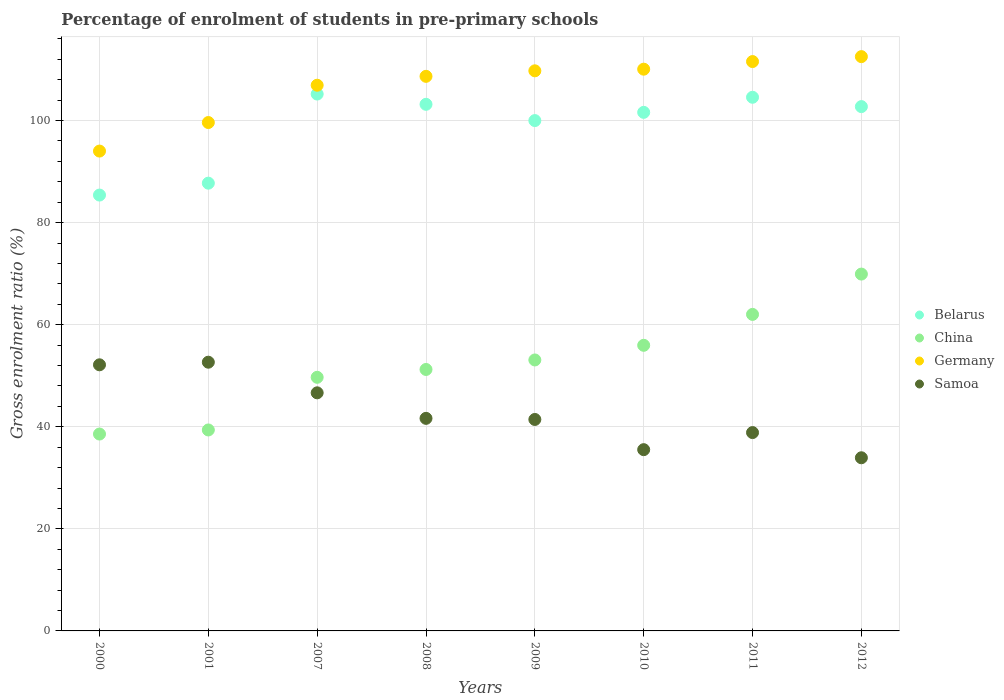How many different coloured dotlines are there?
Offer a very short reply. 4. Is the number of dotlines equal to the number of legend labels?
Your answer should be very brief. Yes. What is the percentage of students enrolled in pre-primary schools in Samoa in 2009?
Your answer should be very brief. 41.43. Across all years, what is the maximum percentage of students enrolled in pre-primary schools in Belarus?
Provide a short and direct response. 105.18. Across all years, what is the minimum percentage of students enrolled in pre-primary schools in Germany?
Provide a short and direct response. 94.01. What is the total percentage of students enrolled in pre-primary schools in China in the graph?
Offer a very short reply. 419.84. What is the difference between the percentage of students enrolled in pre-primary schools in Germany in 2000 and that in 2011?
Make the answer very short. -17.54. What is the difference between the percentage of students enrolled in pre-primary schools in Germany in 2000 and the percentage of students enrolled in pre-primary schools in Belarus in 2007?
Give a very brief answer. -11.17. What is the average percentage of students enrolled in pre-primary schools in Germany per year?
Offer a very short reply. 106.63. In the year 2007, what is the difference between the percentage of students enrolled in pre-primary schools in Germany and percentage of students enrolled in pre-primary schools in Samoa?
Provide a succinct answer. 60.27. In how many years, is the percentage of students enrolled in pre-primary schools in China greater than 28 %?
Provide a succinct answer. 8. What is the ratio of the percentage of students enrolled in pre-primary schools in Germany in 2010 to that in 2012?
Your answer should be compact. 0.98. Is the difference between the percentage of students enrolled in pre-primary schools in Germany in 2001 and 2009 greater than the difference between the percentage of students enrolled in pre-primary schools in Samoa in 2001 and 2009?
Keep it short and to the point. No. What is the difference between the highest and the second highest percentage of students enrolled in pre-primary schools in Belarus?
Keep it short and to the point. 0.63. What is the difference between the highest and the lowest percentage of students enrolled in pre-primary schools in Germany?
Your response must be concise. 18.5. In how many years, is the percentage of students enrolled in pre-primary schools in Belarus greater than the average percentage of students enrolled in pre-primary schools in Belarus taken over all years?
Keep it short and to the point. 6. Is it the case that in every year, the sum of the percentage of students enrolled in pre-primary schools in Samoa and percentage of students enrolled in pre-primary schools in Germany  is greater than the sum of percentage of students enrolled in pre-primary schools in Belarus and percentage of students enrolled in pre-primary schools in China?
Offer a terse response. Yes. Does the percentage of students enrolled in pre-primary schools in Germany monotonically increase over the years?
Make the answer very short. Yes. Is the percentage of students enrolled in pre-primary schools in Samoa strictly less than the percentage of students enrolled in pre-primary schools in China over the years?
Offer a terse response. No. How many dotlines are there?
Ensure brevity in your answer.  4. How many years are there in the graph?
Make the answer very short. 8. Where does the legend appear in the graph?
Provide a succinct answer. Center right. How many legend labels are there?
Your answer should be compact. 4. What is the title of the graph?
Your answer should be compact. Percentage of enrolment of students in pre-primary schools. What is the label or title of the Y-axis?
Give a very brief answer. Gross enrolment ratio (%). What is the Gross enrolment ratio (%) of Belarus in 2000?
Make the answer very short. 85.39. What is the Gross enrolment ratio (%) in China in 2000?
Provide a short and direct response. 38.57. What is the Gross enrolment ratio (%) of Germany in 2000?
Offer a very short reply. 94.01. What is the Gross enrolment ratio (%) of Samoa in 2000?
Give a very brief answer. 52.14. What is the Gross enrolment ratio (%) of Belarus in 2001?
Your answer should be compact. 87.73. What is the Gross enrolment ratio (%) in China in 2001?
Your response must be concise. 39.37. What is the Gross enrolment ratio (%) of Germany in 2001?
Your response must be concise. 99.6. What is the Gross enrolment ratio (%) of Samoa in 2001?
Keep it short and to the point. 52.65. What is the Gross enrolment ratio (%) in Belarus in 2007?
Offer a terse response. 105.18. What is the Gross enrolment ratio (%) in China in 2007?
Offer a very short reply. 49.69. What is the Gross enrolment ratio (%) in Germany in 2007?
Provide a short and direct response. 106.91. What is the Gross enrolment ratio (%) of Samoa in 2007?
Provide a succinct answer. 46.65. What is the Gross enrolment ratio (%) in Belarus in 2008?
Make the answer very short. 103.17. What is the Gross enrolment ratio (%) in China in 2008?
Your answer should be compact. 51.22. What is the Gross enrolment ratio (%) in Germany in 2008?
Ensure brevity in your answer.  108.66. What is the Gross enrolment ratio (%) in Samoa in 2008?
Your response must be concise. 41.65. What is the Gross enrolment ratio (%) in Belarus in 2009?
Your answer should be very brief. 99.99. What is the Gross enrolment ratio (%) in China in 2009?
Ensure brevity in your answer.  53.09. What is the Gross enrolment ratio (%) of Germany in 2009?
Your answer should be very brief. 109.74. What is the Gross enrolment ratio (%) of Samoa in 2009?
Your response must be concise. 41.43. What is the Gross enrolment ratio (%) in Belarus in 2010?
Your response must be concise. 101.6. What is the Gross enrolment ratio (%) in China in 2010?
Your response must be concise. 55.96. What is the Gross enrolment ratio (%) of Germany in 2010?
Your answer should be very brief. 110.06. What is the Gross enrolment ratio (%) of Samoa in 2010?
Ensure brevity in your answer.  35.51. What is the Gross enrolment ratio (%) in Belarus in 2011?
Keep it short and to the point. 104.56. What is the Gross enrolment ratio (%) of China in 2011?
Make the answer very short. 62.01. What is the Gross enrolment ratio (%) of Germany in 2011?
Keep it short and to the point. 111.55. What is the Gross enrolment ratio (%) of Samoa in 2011?
Your response must be concise. 38.86. What is the Gross enrolment ratio (%) in Belarus in 2012?
Keep it short and to the point. 102.73. What is the Gross enrolment ratio (%) of China in 2012?
Provide a succinct answer. 69.91. What is the Gross enrolment ratio (%) of Germany in 2012?
Provide a succinct answer. 112.52. What is the Gross enrolment ratio (%) of Samoa in 2012?
Your answer should be very brief. 33.92. Across all years, what is the maximum Gross enrolment ratio (%) in Belarus?
Make the answer very short. 105.18. Across all years, what is the maximum Gross enrolment ratio (%) in China?
Keep it short and to the point. 69.91. Across all years, what is the maximum Gross enrolment ratio (%) of Germany?
Your response must be concise. 112.52. Across all years, what is the maximum Gross enrolment ratio (%) of Samoa?
Provide a succinct answer. 52.65. Across all years, what is the minimum Gross enrolment ratio (%) of Belarus?
Offer a very short reply. 85.39. Across all years, what is the minimum Gross enrolment ratio (%) in China?
Make the answer very short. 38.57. Across all years, what is the minimum Gross enrolment ratio (%) of Germany?
Provide a short and direct response. 94.01. Across all years, what is the minimum Gross enrolment ratio (%) of Samoa?
Ensure brevity in your answer.  33.92. What is the total Gross enrolment ratio (%) of Belarus in the graph?
Your response must be concise. 790.35. What is the total Gross enrolment ratio (%) in China in the graph?
Keep it short and to the point. 419.84. What is the total Gross enrolment ratio (%) in Germany in the graph?
Give a very brief answer. 853.05. What is the total Gross enrolment ratio (%) of Samoa in the graph?
Offer a terse response. 342.81. What is the difference between the Gross enrolment ratio (%) of Belarus in 2000 and that in 2001?
Offer a terse response. -2.33. What is the difference between the Gross enrolment ratio (%) in China in 2000 and that in 2001?
Make the answer very short. -0.8. What is the difference between the Gross enrolment ratio (%) of Germany in 2000 and that in 2001?
Ensure brevity in your answer.  -5.59. What is the difference between the Gross enrolment ratio (%) in Samoa in 2000 and that in 2001?
Provide a succinct answer. -0.51. What is the difference between the Gross enrolment ratio (%) in Belarus in 2000 and that in 2007?
Provide a succinct answer. -19.79. What is the difference between the Gross enrolment ratio (%) of China in 2000 and that in 2007?
Make the answer very short. -11.12. What is the difference between the Gross enrolment ratio (%) of Germany in 2000 and that in 2007?
Your response must be concise. -12.9. What is the difference between the Gross enrolment ratio (%) in Samoa in 2000 and that in 2007?
Ensure brevity in your answer.  5.49. What is the difference between the Gross enrolment ratio (%) in Belarus in 2000 and that in 2008?
Ensure brevity in your answer.  -17.78. What is the difference between the Gross enrolment ratio (%) in China in 2000 and that in 2008?
Your answer should be very brief. -12.65. What is the difference between the Gross enrolment ratio (%) in Germany in 2000 and that in 2008?
Provide a succinct answer. -14.64. What is the difference between the Gross enrolment ratio (%) in Samoa in 2000 and that in 2008?
Provide a succinct answer. 10.49. What is the difference between the Gross enrolment ratio (%) of Belarus in 2000 and that in 2009?
Your answer should be very brief. -14.59. What is the difference between the Gross enrolment ratio (%) in China in 2000 and that in 2009?
Provide a succinct answer. -14.51. What is the difference between the Gross enrolment ratio (%) in Germany in 2000 and that in 2009?
Ensure brevity in your answer.  -15.72. What is the difference between the Gross enrolment ratio (%) of Samoa in 2000 and that in 2009?
Offer a terse response. 10.71. What is the difference between the Gross enrolment ratio (%) of Belarus in 2000 and that in 2010?
Your answer should be compact. -16.21. What is the difference between the Gross enrolment ratio (%) in China in 2000 and that in 2010?
Your answer should be compact. -17.38. What is the difference between the Gross enrolment ratio (%) of Germany in 2000 and that in 2010?
Keep it short and to the point. -16.05. What is the difference between the Gross enrolment ratio (%) in Samoa in 2000 and that in 2010?
Keep it short and to the point. 16.62. What is the difference between the Gross enrolment ratio (%) in Belarus in 2000 and that in 2011?
Provide a short and direct response. -19.16. What is the difference between the Gross enrolment ratio (%) in China in 2000 and that in 2011?
Ensure brevity in your answer.  -23.44. What is the difference between the Gross enrolment ratio (%) in Germany in 2000 and that in 2011?
Provide a succinct answer. -17.54. What is the difference between the Gross enrolment ratio (%) of Samoa in 2000 and that in 2011?
Provide a short and direct response. 13.28. What is the difference between the Gross enrolment ratio (%) of Belarus in 2000 and that in 2012?
Offer a terse response. -17.33. What is the difference between the Gross enrolment ratio (%) of China in 2000 and that in 2012?
Ensure brevity in your answer.  -31.34. What is the difference between the Gross enrolment ratio (%) of Germany in 2000 and that in 2012?
Keep it short and to the point. -18.5. What is the difference between the Gross enrolment ratio (%) in Samoa in 2000 and that in 2012?
Provide a succinct answer. 18.21. What is the difference between the Gross enrolment ratio (%) of Belarus in 2001 and that in 2007?
Offer a terse response. -17.46. What is the difference between the Gross enrolment ratio (%) in China in 2001 and that in 2007?
Make the answer very short. -10.32. What is the difference between the Gross enrolment ratio (%) in Germany in 2001 and that in 2007?
Provide a succinct answer. -7.31. What is the difference between the Gross enrolment ratio (%) of Samoa in 2001 and that in 2007?
Offer a very short reply. 6. What is the difference between the Gross enrolment ratio (%) in Belarus in 2001 and that in 2008?
Make the answer very short. -15.45. What is the difference between the Gross enrolment ratio (%) in China in 2001 and that in 2008?
Your response must be concise. -11.85. What is the difference between the Gross enrolment ratio (%) of Germany in 2001 and that in 2008?
Make the answer very short. -9.05. What is the difference between the Gross enrolment ratio (%) of Samoa in 2001 and that in 2008?
Give a very brief answer. 11. What is the difference between the Gross enrolment ratio (%) in Belarus in 2001 and that in 2009?
Your answer should be compact. -12.26. What is the difference between the Gross enrolment ratio (%) of China in 2001 and that in 2009?
Your answer should be very brief. -13.71. What is the difference between the Gross enrolment ratio (%) of Germany in 2001 and that in 2009?
Keep it short and to the point. -10.13. What is the difference between the Gross enrolment ratio (%) of Samoa in 2001 and that in 2009?
Keep it short and to the point. 11.22. What is the difference between the Gross enrolment ratio (%) of Belarus in 2001 and that in 2010?
Provide a succinct answer. -13.87. What is the difference between the Gross enrolment ratio (%) in China in 2001 and that in 2010?
Make the answer very short. -16.59. What is the difference between the Gross enrolment ratio (%) in Germany in 2001 and that in 2010?
Keep it short and to the point. -10.45. What is the difference between the Gross enrolment ratio (%) of Samoa in 2001 and that in 2010?
Offer a very short reply. 17.14. What is the difference between the Gross enrolment ratio (%) in Belarus in 2001 and that in 2011?
Provide a succinct answer. -16.83. What is the difference between the Gross enrolment ratio (%) of China in 2001 and that in 2011?
Your answer should be very brief. -22.64. What is the difference between the Gross enrolment ratio (%) of Germany in 2001 and that in 2011?
Provide a succinct answer. -11.95. What is the difference between the Gross enrolment ratio (%) of Samoa in 2001 and that in 2011?
Offer a terse response. 13.79. What is the difference between the Gross enrolment ratio (%) in Belarus in 2001 and that in 2012?
Provide a short and direct response. -15. What is the difference between the Gross enrolment ratio (%) of China in 2001 and that in 2012?
Offer a very short reply. -30.54. What is the difference between the Gross enrolment ratio (%) in Germany in 2001 and that in 2012?
Give a very brief answer. -12.91. What is the difference between the Gross enrolment ratio (%) in Samoa in 2001 and that in 2012?
Keep it short and to the point. 18.72. What is the difference between the Gross enrolment ratio (%) of Belarus in 2007 and that in 2008?
Ensure brevity in your answer.  2.01. What is the difference between the Gross enrolment ratio (%) in China in 2007 and that in 2008?
Ensure brevity in your answer.  -1.54. What is the difference between the Gross enrolment ratio (%) in Germany in 2007 and that in 2008?
Give a very brief answer. -1.74. What is the difference between the Gross enrolment ratio (%) in Samoa in 2007 and that in 2008?
Your answer should be very brief. 5. What is the difference between the Gross enrolment ratio (%) of Belarus in 2007 and that in 2009?
Make the answer very short. 5.2. What is the difference between the Gross enrolment ratio (%) of China in 2007 and that in 2009?
Provide a succinct answer. -3.4. What is the difference between the Gross enrolment ratio (%) of Germany in 2007 and that in 2009?
Your answer should be compact. -2.82. What is the difference between the Gross enrolment ratio (%) of Samoa in 2007 and that in 2009?
Offer a terse response. 5.22. What is the difference between the Gross enrolment ratio (%) of Belarus in 2007 and that in 2010?
Provide a short and direct response. 3.58. What is the difference between the Gross enrolment ratio (%) of China in 2007 and that in 2010?
Keep it short and to the point. -6.27. What is the difference between the Gross enrolment ratio (%) of Germany in 2007 and that in 2010?
Make the answer very short. -3.15. What is the difference between the Gross enrolment ratio (%) of Samoa in 2007 and that in 2010?
Make the answer very short. 11.13. What is the difference between the Gross enrolment ratio (%) in Belarus in 2007 and that in 2011?
Provide a short and direct response. 0.63. What is the difference between the Gross enrolment ratio (%) in China in 2007 and that in 2011?
Keep it short and to the point. -12.32. What is the difference between the Gross enrolment ratio (%) of Germany in 2007 and that in 2011?
Give a very brief answer. -4.64. What is the difference between the Gross enrolment ratio (%) of Samoa in 2007 and that in 2011?
Give a very brief answer. 7.79. What is the difference between the Gross enrolment ratio (%) in Belarus in 2007 and that in 2012?
Offer a terse response. 2.46. What is the difference between the Gross enrolment ratio (%) of China in 2007 and that in 2012?
Your answer should be compact. -20.22. What is the difference between the Gross enrolment ratio (%) in Germany in 2007 and that in 2012?
Ensure brevity in your answer.  -5.6. What is the difference between the Gross enrolment ratio (%) in Samoa in 2007 and that in 2012?
Give a very brief answer. 12.72. What is the difference between the Gross enrolment ratio (%) in Belarus in 2008 and that in 2009?
Your answer should be compact. 3.19. What is the difference between the Gross enrolment ratio (%) in China in 2008 and that in 2009?
Your answer should be very brief. -1.86. What is the difference between the Gross enrolment ratio (%) in Germany in 2008 and that in 2009?
Ensure brevity in your answer.  -1.08. What is the difference between the Gross enrolment ratio (%) in Samoa in 2008 and that in 2009?
Give a very brief answer. 0.22. What is the difference between the Gross enrolment ratio (%) in Belarus in 2008 and that in 2010?
Provide a succinct answer. 1.57. What is the difference between the Gross enrolment ratio (%) in China in 2008 and that in 2010?
Keep it short and to the point. -4.73. What is the difference between the Gross enrolment ratio (%) in Germany in 2008 and that in 2010?
Provide a short and direct response. -1.4. What is the difference between the Gross enrolment ratio (%) of Samoa in 2008 and that in 2010?
Give a very brief answer. 6.13. What is the difference between the Gross enrolment ratio (%) of Belarus in 2008 and that in 2011?
Provide a short and direct response. -1.38. What is the difference between the Gross enrolment ratio (%) of China in 2008 and that in 2011?
Your response must be concise. -10.79. What is the difference between the Gross enrolment ratio (%) in Germany in 2008 and that in 2011?
Keep it short and to the point. -2.89. What is the difference between the Gross enrolment ratio (%) in Samoa in 2008 and that in 2011?
Offer a very short reply. 2.79. What is the difference between the Gross enrolment ratio (%) of Belarus in 2008 and that in 2012?
Offer a very short reply. 0.45. What is the difference between the Gross enrolment ratio (%) of China in 2008 and that in 2012?
Provide a succinct answer. -18.69. What is the difference between the Gross enrolment ratio (%) of Germany in 2008 and that in 2012?
Offer a terse response. -3.86. What is the difference between the Gross enrolment ratio (%) of Samoa in 2008 and that in 2012?
Offer a very short reply. 7.72. What is the difference between the Gross enrolment ratio (%) of Belarus in 2009 and that in 2010?
Keep it short and to the point. -1.61. What is the difference between the Gross enrolment ratio (%) in China in 2009 and that in 2010?
Give a very brief answer. -2.87. What is the difference between the Gross enrolment ratio (%) of Germany in 2009 and that in 2010?
Provide a short and direct response. -0.32. What is the difference between the Gross enrolment ratio (%) of Samoa in 2009 and that in 2010?
Give a very brief answer. 5.92. What is the difference between the Gross enrolment ratio (%) in Belarus in 2009 and that in 2011?
Your answer should be compact. -4.57. What is the difference between the Gross enrolment ratio (%) in China in 2009 and that in 2011?
Your answer should be very brief. -8.93. What is the difference between the Gross enrolment ratio (%) of Germany in 2009 and that in 2011?
Make the answer very short. -1.81. What is the difference between the Gross enrolment ratio (%) in Samoa in 2009 and that in 2011?
Your answer should be compact. 2.57. What is the difference between the Gross enrolment ratio (%) of Belarus in 2009 and that in 2012?
Provide a short and direct response. -2.74. What is the difference between the Gross enrolment ratio (%) in China in 2009 and that in 2012?
Offer a terse response. -16.83. What is the difference between the Gross enrolment ratio (%) of Germany in 2009 and that in 2012?
Your response must be concise. -2.78. What is the difference between the Gross enrolment ratio (%) in Samoa in 2009 and that in 2012?
Keep it short and to the point. 7.5. What is the difference between the Gross enrolment ratio (%) of Belarus in 2010 and that in 2011?
Make the answer very short. -2.96. What is the difference between the Gross enrolment ratio (%) of China in 2010 and that in 2011?
Ensure brevity in your answer.  -6.06. What is the difference between the Gross enrolment ratio (%) of Germany in 2010 and that in 2011?
Your response must be concise. -1.49. What is the difference between the Gross enrolment ratio (%) of Samoa in 2010 and that in 2011?
Give a very brief answer. -3.35. What is the difference between the Gross enrolment ratio (%) of Belarus in 2010 and that in 2012?
Keep it short and to the point. -1.13. What is the difference between the Gross enrolment ratio (%) of China in 2010 and that in 2012?
Your answer should be compact. -13.95. What is the difference between the Gross enrolment ratio (%) in Germany in 2010 and that in 2012?
Your answer should be compact. -2.46. What is the difference between the Gross enrolment ratio (%) in Samoa in 2010 and that in 2012?
Keep it short and to the point. 1.59. What is the difference between the Gross enrolment ratio (%) in Belarus in 2011 and that in 2012?
Ensure brevity in your answer.  1.83. What is the difference between the Gross enrolment ratio (%) in China in 2011 and that in 2012?
Keep it short and to the point. -7.9. What is the difference between the Gross enrolment ratio (%) in Germany in 2011 and that in 2012?
Keep it short and to the point. -0.97. What is the difference between the Gross enrolment ratio (%) of Samoa in 2011 and that in 2012?
Your answer should be very brief. 4.93. What is the difference between the Gross enrolment ratio (%) of Belarus in 2000 and the Gross enrolment ratio (%) of China in 2001?
Provide a short and direct response. 46.02. What is the difference between the Gross enrolment ratio (%) in Belarus in 2000 and the Gross enrolment ratio (%) in Germany in 2001?
Provide a succinct answer. -14.21. What is the difference between the Gross enrolment ratio (%) in Belarus in 2000 and the Gross enrolment ratio (%) in Samoa in 2001?
Your answer should be compact. 32.75. What is the difference between the Gross enrolment ratio (%) of China in 2000 and the Gross enrolment ratio (%) of Germany in 2001?
Ensure brevity in your answer.  -61.03. What is the difference between the Gross enrolment ratio (%) in China in 2000 and the Gross enrolment ratio (%) in Samoa in 2001?
Your answer should be compact. -14.07. What is the difference between the Gross enrolment ratio (%) of Germany in 2000 and the Gross enrolment ratio (%) of Samoa in 2001?
Offer a very short reply. 41.36. What is the difference between the Gross enrolment ratio (%) of Belarus in 2000 and the Gross enrolment ratio (%) of China in 2007?
Offer a very short reply. 35.7. What is the difference between the Gross enrolment ratio (%) of Belarus in 2000 and the Gross enrolment ratio (%) of Germany in 2007?
Your answer should be compact. -21.52. What is the difference between the Gross enrolment ratio (%) of Belarus in 2000 and the Gross enrolment ratio (%) of Samoa in 2007?
Offer a very short reply. 38.75. What is the difference between the Gross enrolment ratio (%) in China in 2000 and the Gross enrolment ratio (%) in Germany in 2007?
Offer a very short reply. -68.34. What is the difference between the Gross enrolment ratio (%) of China in 2000 and the Gross enrolment ratio (%) of Samoa in 2007?
Give a very brief answer. -8.07. What is the difference between the Gross enrolment ratio (%) in Germany in 2000 and the Gross enrolment ratio (%) in Samoa in 2007?
Offer a terse response. 47.36. What is the difference between the Gross enrolment ratio (%) in Belarus in 2000 and the Gross enrolment ratio (%) in China in 2008?
Give a very brief answer. 34.17. What is the difference between the Gross enrolment ratio (%) in Belarus in 2000 and the Gross enrolment ratio (%) in Germany in 2008?
Offer a very short reply. -23.26. What is the difference between the Gross enrolment ratio (%) of Belarus in 2000 and the Gross enrolment ratio (%) of Samoa in 2008?
Offer a very short reply. 43.75. What is the difference between the Gross enrolment ratio (%) in China in 2000 and the Gross enrolment ratio (%) in Germany in 2008?
Provide a succinct answer. -70.08. What is the difference between the Gross enrolment ratio (%) in China in 2000 and the Gross enrolment ratio (%) in Samoa in 2008?
Keep it short and to the point. -3.07. What is the difference between the Gross enrolment ratio (%) in Germany in 2000 and the Gross enrolment ratio (%) in Samoa in 2008?
Your response must be concise. 52.37. What is the difference between the Gross enrolment ratio (%) in Belarus in 2000 and the Gross enrolment ratio (%) in China in 2009?
Provide a succinct answer. 32.31. What is the difference between the Gross enrolment ratio (%) of Belarus in 2000 and the Gross enrolment ratio (%) of Germany in 2009?
Your answer should be compact. -24.34. What is the difference between the Gross enrolment ratio (%) of Belarus in 2000 and the Gross enrolment ratio (%) of Samoa in 2009?
Your answer should be compact. 43.96. What is the difference between the Gross enrolment ratio (%) in China in 2000 and the Gross enrolment ratio (%) in Germany in 2009?
Offer a very short reply. -71.16. What is the difference between the Gross enrolment ratio (%) of China in 2000 and the Gross enrolment ratio (%) of Samoa in 2009?
Provide a succinct answer. -2.86. What is the difference between the Gross enrolment ratio (%) of Germany in 2000 and the Gross enrolment ratio (%) of Samoa in 2009?
Your response must be concise. 52.58. What is the difference between the Gross enrolment ratio (%) in Belarus in 2000 and the Gross enrolment ratio (%) in China in 2010?
Offer a terse response. 29.44. What is the difference between the Gross enrolment ratio (%) of Belarus in 2000 and the Gross enrolment ratio (%) of Germany in 2010?
Your answer should be very brief. -24.66. What is the difference between the Gross enrolment ratio (%) of Belarus in 2000 and the Gross enrolment ratio (%) of Samoa in 2010?
Ensure brevity in your answer.  49.88. What is the difference between the Gross enrolment ratio (%) of China in 2000 and the Gross enrolment ratio (%) of Germany in 2010?
Your response must be concise. -71.48. What is the difference between the Gross enrolment ratio (%) in China in 2000 and the Gross enrolment ratio (%) in Samoa in 2010?
Make the answer very short. 3.06. What is the difference between the Gross enrolment ratio (%) in Germany in 2000 and the Gross enrolment ratio (%) in Samoa in 2010?
Give a very brief answer. 58.5. What is the difference between the Gross enrolment ratio (%) in Belarus in 2000 and the Gross enrolment ratio (%) in China in 2011?
Offer a very short reply. 23.38. What is the difference between the Gross enrolment ratio (%) of Belarus in 2000 and the Gross enrolment ratio (%) of Germany in 2011?
Your answer should be very brief. -26.16. What is the difference between the Gross enrolment ratio (%) in Belarus in 2000 and the Gross enrolment ratio (%) in Samoa in 2011?
Offer a terse response. 46.54. What is the difference between the Gross enrolment ratio (%) in China in 2000 and the Gross enrolment ratio (%) in Germany in 2011?
Give a very brief answer. -72.98. What is the difference between the Gross enrolment ratio (%) in China in 2000 and the Gross enrolment ratio (%) in Samoa in 2011?
Provide a succinct answer. -0.28. What is the difference between the Gross enrolment ratio (%) of Germany in 2000 and the Gross enrolment ratio (%) of Samoa in 2011?
Your response must be concise. 55.15. What is the difference between the Gross enrolment ratio (%) in Belarus in 2000 and the Gross enrolment ratio (%) in China in 2012?
Give a very brief answer. 15.48. What is the difference between the Gross enrolment ratio (%) in Belarus in 2000 and the Gross enrolment ratio (%) in Germany in 2012?
Provide a succinct answer. -27.12. What is the difference between the Gross enrolment ratio (%) in Belarus in 2000 and the Gross enrolment ratio (%) in Samoa in 2012?
Offer a very short reply. 51.47. What is the difference between the Gross enrolment ratio (%) in China in 2000 and the Gross enrolment ratio (%) in Germany in 2012?
Offer a very short reply. -73.94. What is the difference between the Gross enrolment ratio (%) of China in 2000 and the Gross enrolment ratio (%) of Samoa in 2012?
Ensure brevity in your answer.  4.65. What is the difference between the Gross enrolment ratio (%) in Germany in 2000 and the Gross enrolment ratio (%) in Samoa in 2012?
Provide a short and direct response. 60.09. What is the difference between the Gross enrolment ratio (%) of Belarus in 2001 and the Gross enrolment ratio (%) of China in 2007?
Make the answer very short. 38.04. What is the difference between the Gross enrolment ratio (%) in Belarus in 2001 and the Gross enrolment ratio (%) in Germany in 2007?
Your answer should be compact. -19.19. What is the difference between the Gross enrolment ratio (%) of Belarus in 2001 and the Gross enrolment ratio (%) of Samoa in 2007?
Provide a succinct answer. 41.08. What is the difference between the Gross enrolment ratio (%) in China in 2001 and the Gross enrolment ratio (%) in Germany in 2007?
Ensure brevity in your answer.  -67.54. What is the difference between the Gross enrolment ratio (%) in China in 2001 and the Gross enrolment ratio (%) in Samoa in 2007?
Ensure brevity in your answer.  -7.27. What is the difference between the Gross enrolment ratio (%) of Germany in 2001 and the Gross enrolment ratio (%) of Samoa in 2007?
Your response must be concise. 52.96. What is the difference between the Gross enrolment ratio (%) of Belarus in 2001 and the Gross enrolment ratio (%) of China in 2008?
Keep it short and to the point. 36.5. What is the difference between the Gross enrolment ratio (%) of Belarus in 2001 and the Gross enrolment ratio (%) of Germany in 2008?
Make the answer very short. -20.93. What is the difference between the Gross enrolment ratio (%) of Belarus in 2001 and the Gross enrolment ratio (%) of Samoa in 2008?
Offer a very short reply. 46.08. What is the difference between the Gross enrolment ratio (%) of China in 2001 and the Gross enrolment ratio (%) of Germany in 2008?
Provide a succinct answer. -69.28. What is the difference between the Gross enrolment ratio (%) in China in 2001 and the Gross enrolment ratio (%) in Samoa in 2008?
Your response must be concise. -2.27. What is the difference between the Gross enrolment ratio (%) of Germany in 2001 and the Gross enrolment ratio (%) of Samoa in 2008?
Your answer should be compact. 57.96. What is the difference between the Gross enrolment ratio (%) of Belarus in 2001 and the Gross enrolment ratio (%) of China in 2009?
Ensure brevity in your answer.  34.64. What is the difference between the Gross enrolment ratio (%) in Belarus in 2001 and the Gross enrolment ratio (%) in Germany in 2009?
Offer a very short reply. -22.01. What is the difference between the Gross enrolment ratio (%) in Belarus in 2001 and the Gross enrolment ratio (%) in Samoa in 2009?
Offer a very short reply. 46.3. What is the difference between the Gross enrolment ratio (%) in China in 2001 and the Gross enrolment ratio (%) in Germany in 2009?
Give a very brief answer. -70.36. What is the difference between the Gross enrolment ratio (%) of China in 2001 and the Gross enrolment ratio (%) of Samoa in 2009?
Keep it short and to the point. -2.06. What is the difference between the Gross enrolment ratio (%) of Germany in 2001 and the Gross enrolment ratio (%) of Samoa in 2009?
Keep it short and to the point. 58.18. What is the difference between the Gross enrolment ratio (%) of Belarus in 2001 and the Gross enrolment ratio (%) of China in 2010?
Offer a very short reply. 31.77. What is the difference between the Gross enrolment ratio (%) of Belarus in 2001 and the Gross enrolment ratio (%) of Germany in 2010?
Provide a short and direct response. -22.33. What is the difference between the Gross enrolment ratio (%) in Belarus in 2001 and the Gross enrolment ratio (%) in Samoa in 2010?
Make the answer very short. 52.21. What is the difference between the Gross enrolment ratio (%) of China in 2001 and the Gross enrolment ratio (%) of Germany in 2010?
Provide a succinct answer. -70.69. What is the difference between the Gross enrolment ratio (%) in China in 2001 and the Gross enrolment ratio (%) in Samoa in 2010?
Ensure brevity in your answer.  3.86. What is the difference between the Gross enrolment ratio (%) in Germany in 2001 and the Gross enrolment ratio (%) in Samoa in 2010?
Offer a terse response. 64.09. What is the difference between the Gross enrolment ratio (%) of Belarus in 2001 and the Gross enrolment ratio (%) of China in 2011?
Offer a terse response. 25.71. What is the difference between the Gross enrolment ratio (%) of Belarus in 2001 and the Gross enrolment ratio (%) of Germany in 2011?
Your response must be concise. -23.83. What is the difference between the Gross enrolment ratio (%) of Belarus in 2001 and the Gross enrolment ratio (%) of Samoa in 2011?
Keep it short and to the point. 48.87. What is the difference between the Gross enrolment ratio (%) of China in 2001 and the Gross enrolment ratio (%) of Germany in 2011?
Your answer should be very brief. -72.18. What is the difference between the Gross enrolment ratio (%) in China in 2001 and the Gross enrolment ratio (%) in Samoa in 2011?
Your response must be concise. 0.51. What is the difference between the Gross enrolment ratio (%) in Germany in 2001 and the Gross enrolment ratio (%) in Samoa in 2011?
Keep it short and to the point. 60.75. What is the difference between the Gross enrolment ratio (%) of Belarus in 2001 and the Gross enrolment ratio (%) of China in 2012?
Keep it short and to the point. 17.81. What is the difference between the Gross enrolment ratio (%) of Belarus in 2001 and the Gross enrolment ratio (%) of Germany in 2012?
Offer a very short reply. -24.79. What is the difference between the Gross enrolment ratio (%) of Belarus in 2001 and the Gross enrolment ratio (%) of Samoa in 2012?
Make the answer very short. 53.8. What is the difference between the Gross enrolment ratio (%) in China in 2001 and the Gross enrolment ratio (%) in Germany in 2012?
Offer a terse response. -73.14. What is the difference between the Gross enrolment ratio (%) in China in 2001 and the Gross enrolment ratio (%) in Samoa in 2012?
Provide a short and direct response. 5.45. What is the difference between the Gross enrolment ratio (%) in Germany in 2001 and the Gross enrolment ratio (%) in Samoa in 2012?
Give a very brief answer. 65.68. What is the difference between the Gross enrolment ratio (%) in Belarus in 2007 and the Gross enrolment ratio (%) in China in 2008?
Your answer should be compact. 53.96. What is the difference between the Gross enrolment ratio (%) in Belarus in 2007 and the Gross enrolment ratio (%) in Germany in 2008?
Keep it short and to the point. -3.47. What is the difference between the Gross enrolment ratio (%) in Belarus in 2007 and the Gross enrolment ratio (%) in Samoa in 2008?
Ensure brevity in your answer.  63.54. What is the difference between the Gross enrolment ratio (%) of China in 2007 and the Gross enrolment ratio (%) of Germany in 2008?
Your answer should be compact. -58.97. What is the difference between the Gross enrolment ratio (%) of China in 2007 and the Gross enrolment ratio (%) of Samoa in 2008?
Keep it short and to the point. 8.04. What is the difference between the Gross enrolment ratio (%) in Germany in 2007 and the Gross enrolment ratio (%) in Samoa in 2008?
Offer a terse response. 65.27. What is the difference between the Gross enrolment ratio (%) in Belarus in 2007 and the Gross enrolment ratio (%) in China in 2009?
Make the answer very short. 52.1. What is the difference between the Gross enrolment ratio (%) in Belarus in 2007 and the Gross enrolment ratio (%) in Germany in 2009?
Make the answer very short. -4.55. What is the difference between the Gross enrolment ratio (%) in Belarus in 2007 and the Gross enrolment ratio (%) in Samoa in 2009?
Ensure brevity in your answer.  63.75. What is the difference between the Gross enrolment ratio (%) of China in 2007 and the Gross enrolment ratio (%) of Germany in 2009?
Offer a terse response. -60.05. What is the difference between the Gross enrolment ratio (%) in China in 2007 and the Gross enrolment ratio (%) in Samoa in 2009?
Offer a very short reply. 8.26. What is the difference between the Gross enrolment ratio (%) in Germany in 2007 and the Gross enrolment ratio (%) in Samoa in 2009?
Give a very brief answer. 65.48. What is the difference between the Gross enrolment ratio (%) in Belarus in 2007 and the Gross enrolment ratio (%) in China in 2010?
Provide a succinct answer. 49.23. What is the difference between the Gross enrolment ratio (%) in Belarus in 2007 and the Gross enrolment ratio (%) in Germany in 2010?
Provide a succinct answer. -4.87. What is the difference between the Gross enrolment ratio (%) in Belarus in 2007 and the Gross enrolment ratio (%) in Samoa in 2010?
Keep it short and to the point. 69.67. What is the difference between the Gross enrolment ratio (%) in China in 2007 and the Gross enrolment ratio (%) in Germany in 2010?
Make the answer very short. -60.37. What is the difference between the Gross enrolment ratio (%) in China in 2007 and the Gross enrolment ratio (%) in Samoa in 2010?
Give a very brief answer. 14.18. What is the difference between the Gross enrolment ratio (%) in Germany in 2007 and the Gross enrolment ratio (%) in Samoa in 2010?
Offer a very short reply. 71.4. What is the difference between the Gross enrolment ratio (%) of Belarus in 2007 and the Gross enrolment ratio (%) of China in 2011?
Offer a very short reply. 43.17. What is the difference between the Gross enrolment ratio (%) of Belarus in 2007 and the Gross enrolment ratio (%) of Germany in 2011?
Your answer should be compact. -6.37. What is the difference between the Gross enrolment ratio (%) of Belarus in 2007 and the Gross enrolment ratio (%) of Samoa in 2011?
Your answer should be compact. 66.33. What is the difference between the Gross enrolment ratio (%) in China in 2007 and the Gross enrolment ratio (%) in Germany in 2011?
Make the answer very short. -61.86. What is the difference between the Gross enrolment ratio (%) in China in 2007 and the Gross enrolment ratio (%) in Samoa in 2011?
Your response must be concise. 10.83. What is the difference between the Gross enrolment ratio (%) of Germany in 2007 and the Gross enrolment ratio (%) of Samoa in 2011?
Keep it short and to the point. 68.05. What is the difference between the Gross enrolment ratio (%) in Belarus in 2007 and the Gross enrolment ratio (%) in China in 2012?
Keep it short and to the point. 35.27. What is the difference between the Gross enrolment ratio (%) in Belarus in 2007 and the Gross enrolment ratio (%) in Germany in 2012?
Your answer should be very brief. -7.33. What is the difference between the Gross enrolment ratio (%) of Belarus in 2007 and the Gross enrolment ratio (%) of Samoa in 2012?
Make the answer very short. 71.26. What is the difference between the Gross enrolment ratio (%) of China in 2007 and the Gross enrolment ratio (%) of Germany in 2012?
Ensure brevity in your answer.  -62.83. What is the difference between the Gross enrolment ratio (%) of China in 2007 and the Gross enrolment ratio (%) of Samoa in 2012?
Your answer should be very brief. 15.76. What is the difference between the Gross enrolment ratio (%) of Germany in 2007 and the Gross enrolment ratio (%) of Samoa in 2012?
Make the answer very short. 72.99. What is the difference between the Gross enrolment ratio (%) of Belarus in 2008 and the Gross enrolment ratio (%) of China in 2009?
Keep it short and to the point. 50.09. What is the difference between the Gross enrolment ratio (%) of Belarus in 2008 and the Gross enrolment ratio (%) of Germany in 2009?
Your answer should be very brief. -6.56. What is the difference between the Gross enrolment ratio (%) in Belarus in 2008 and the Gross enrolment ratio (%) in Samoa in 2009?
Your response must be concise. 61.74. What is the difference between the Gross enrolment ratio (%) in China in 2008 and the Gross enrolment ratio (%) in Germany in 2009?
Make the answer very short. -58.51. What is the difference between the Gross enrolment ratio (%) of China in 2008 and the Gross enrolment ratio (%) of Samoa in 2009?
Provide a succinct answer. 9.8. What is the difference between the Gross enrolment ratio (%) in Germany in 2008 and the Gross enrolment ratio (%) in Samoa in 2009?
Ensure brevity in your answer.  67.23. What is the difference between the Gross enrolment ratio (%) in Belarus in 2008 and the Gross enrolment ratio (%) in China in 2010?
Ensure brevity in your answer.  47.21. What is the difference between the Gross enrolment ratio (%) in Belarus in 2008 and the Gross enrolment ratio (%) in Germany in 2010?
Offer a terse response. -6.89. What is the difference between the Gross enrolment ratio (%) of Belarus in 2008 and the Gross enrolment ratio (%) of Samoa in 2010?
Offer a very short reply. 67.66. What is the difference between the Gross enrolment ratio (%) of China in 2008 and the Gross enrolment ratio (%) of Germany in 2010?
Make the answer very short. -58.83. What is the difference between the Gross enrolment ratio (%) in China in 2008 and the Gross enrolment ratio (%) in Samoa in 2010?
Ensure brevity in your answer.  15.71. What is the difference between the Gross enrolment ratio (%) in Germany in 2008 and the Gross enrolment ratio (%) in Samoa in 2010?
Offer a very short reply. 73.14. What is the difference between the Gross enrolment ratio (%) in Belarus in 2008 and the Gross enrolment ratio (%) in China in 2011?
Your answer should be compact. 41.16. What is the difference between the Gross enrolment ratio (%) in Belarus in 2008 and the Gross enrolment ratio (%) in Germany in 2011?
Your answer should be very brief. -8.38. What is the difference between the Gross enrolment ratio (%) of Belarus in 2008 and the Gross enrolment ratio (%) of Samoa in 2011?
Provide a succinct answer. 64.31. What is the difference between the Gross enrolment ratio (%) of China in 2008 and the Gross enrolment ratio (%) of Germany in 2011?
Give a very brief answer. -60.33. What is the difference between the Gross enrolment ratio (%) in China in 2008 and the Gross enrolment ratio (%) in Samoa in 2011?
Your answer should be very brief. 12.37. What is the difference between the Gross enrolment ratio (%) of Germany in 2008 and the Gross enrolment ratio (%) of Samoa in 2011?
Give a very brief answer. 69.8. What is the difference between the Gross enrolment ratio (%) of Belarus in 2008 and the Gross enrolment ratio (%) of China in 2012?
Your answer should be very brief. 33.26. What is the difference between the Gross enrolment ratio (%) in Belarus in 2008 and the Gross enrolment ratio (%) in Germany in 2012?
Your answer should be very brief. -9.34. What is the difference between the Gross enrolment ratio (%) in Belarus in 2008 and the Gross enrolment ratio (%) in Samoa in 2012?
Offer a very short reply. 69.25. What is the difference between the Gross enrolment ratio (%) in China in 2008 and the Gross enrolment ratio (%) in Germany in 2012?
Offer a terse response. -61.29. What is the difference between the Gross enrolment ratio (%) in Germany in 2008 and the Gross enrolment ratio (%) in Samoa in 2012?
Your answer should be very brief. 74.73. What is the difference between the Gross enrolment ratio (%) of Belarus in 2009 and the Gross enrolment ratio (%) of China in 2010?
Offer a terse response. 44.03. What is the difference between the Gross enrolment ratio (%) in Belarus in 2009 and the Gross enrolment ratio (%) in Germany in 2010?
Offer a very short reply. -10.07. What is the difference between the Gross enrolment ratio (%) in Belarus in 2009 and the Gross enrolment ratio (%) in Samoa in 2010?
Offer a very short reply. 64.47. What is the difference between the Gross enrolment ratio (%) in China in 2009 and the Gross enrolment ratio (%) in Germany in 2010?
Your answer should be compact. -56.97. What is the difference between the Gross enrolment ratio (%) in China in 2009 and the Gross enrolment ratio (%) in Samoa in 2010?
Provide a short and direct response. 17.57. What is the difference between the Gross enrolment ratio (%) of Germany in 2009 and the Gross enrolment ratio (%) of Samoa in 2010?
Ensure brevity in your answer.  74.22. What is the difference between the Gross enrolment ratio (%) of Belarus in 2009 and the Gross enrolment ratio (%) of China in 2011?
Keep it short and to the point. 37.97. What is the difference between the Gross enrolment ratio (%) in Belarus in 2009 and the Gross enrolment ratio (%) in Germany in 2011?
Offer a very short reply. -11.56. What is the difference between the Gross enrolment ratio (%) in Belarus in 2009 and the Gross enrolment ratio (%) in Samoa in 2011?
Offer a terse response. 61.13. What is the difference between the Gross enrolment ratio (%) in China in 2009 and the Gross enrolment ratio (%) in Germany in 2011?
Your response must be concise. -58.46. What is the difference between the Gross enrolment ratio (%) in China in 2009 and the Gross enrolment ratio (%) in Samoa in 2011?
Offer a terse response. 14.23. What is the difference between the Gross enrolment ratio (%) in Germany in 2009 and the Gross enrolment ratio (%) in Samoa in 2011?
Your answer should be compact. 70.88. What is the difference between the Gross enrolment ratio (%) of Belarus in 2009 and the Gross enrolment ratio (%) of China in 2012?
Offer a terse response. 30.07. What is the difference between the Gross enrolment ratio (%) in Belarus in 2009 and the Gross enrolment ratio (%) in Germany in 2012?
Ensure brevity in your answer.  -12.53. What is the difference between the Gross enrolment ratio (%) of Belarus in 2009 and the Gross enrolment ratio (%) of Samoa in 2012?
Provide a short and direct response. 66.06. What is the difference between the Gross enrolment ratio (%) in China in 2009 and the Gross enrolment ratio (%) in Germany in 2012?
Make the answer very short. -59.43. What is the difference between the Gross enrolment ratio (%) of China in 2009 and the Gross enrolment ratio (%) of Samoa in 2012?
Your answer should be very brief. 19.16. What is the difference between the Gross enrolment ratio (%) in Germany in 2009 and the Gross enrolment ratio (%) in Samoa in 2012?
Your response must be concise. 75.81. What is the difference between the Gross enrolment ratio (%) of Belarus in 2010 and the Gross enrolment ratio (%) of China in 2011?
Offer a very short reply. 39.59. What is the difference between the Gross enrolment ratio (%) in Belarus in 2010 and the Gross enrolment ratio (%) in Germany in 2011?
Keep it short and to the point. -9.95. What is the difference between the Gross enrolment ratio (%) of Belarus in 2010 and the Gross enrolment ratio (%) of Samoa in 2011?
Keep it short and to the point. 62.74. What is the difference between the Gross enrolment ratio (%) of China in 2010 and the Gross enrolment ratio (%) of Germany in 2011?
Your answer should be compact. -55.59. What is the difference between the Gross enrolment ratio (%) in China in 2010 and the Gross enrolment ratio (%) in Samoa in 2011?
Offer a terse response. 17.1. What is the difference between the Gross enrolment ratio (%) of Germany in 2010 and the Gross enrolment ratio (%) of Samoa in 2011?
Make the answer very short. 71.2. What is the difference between the Gross enrolment ratio (%) of Belarus in 2010 and the Gross enrolment ratio (%) of China in 2012?
Ensure brevity in your answer.  31.69. What is the difference between the Gross enrolment ratio (%) of Belarus in 2010 and the Gross enrolment ratio (%) of Germany in 2012?
Ensure brevity in your answer.  -10.92. What is the difference between the Gross enrolment ratio (%) of Belarus in 2010 and the Gross enrolment ratio (%) of Samoa in 2012?
Offer a very short reply. 67.68. What is the difference between the Gross enrolment ratio (%) in China in 2010 and the Gross enrolment ratio (%) in Germany in 2012?
Provide a succinct answer. -56.56. What is the difference between the Gross enrolment ratio (%) in China in 2010 and the Gross enrolment ratio (%) in Samoa in 2012?
Give a very brief answer. 22.03. What is the difference between the Gross enrolment ratio (%) of Germany in 2010 and the Gross enrolment ratio (%) of Samoa in 2012?
Your response must be concise. 76.13. What is the difference between the Gross enrolment ratio (%) of Belarus in 2011 and the Gross enrolment ratio (%) of China in 2012?
Ensure brevity in your answer.  34.64. What is the difference between the Gross enrolment ratio (%) in Belarus in 2011 and the Gross enrolment ratio (%) in Germany in 2012?
Offer a terse response. -7.96. What is the difference between the Gross enrolment ratio (%) of Belarus in 2011 and the Gross enrolment ratio (%) of Samoa in 2012?
Provide a short and direct response. 70.63. What is the difference between the Gross enrolment ratio (%) of China in 2011 and the Gross enrolment ratio (%) of Germany in 2012?
Ensure brevity in your answer.  -50.5. What is the difference between the Gross enrolment ratio (%) of China in 2011 and the Gross enrolment ratio (%) of Samoa in 2012?
Offer a very short reply. 28.09. What is the difference between the Gross enrolment ratio (%) in Germany in 2011 and the Gross enrolment ratio (%) in Samoa in 2012?
Ensure brevity in your answer.  77.63. What is the average Gross enrolment ratio (%) of Belarus per year?
Your response must be concise. 98.79. What is the average Gross enrolment ratio (%) of China per year?
Make the answer very short. 52.48. What is the average Gross enrolment ratio (%) in Germany per year?
Ensure brevity in your answer.  106.63. What is the average Gross enrolment ratio (%) of Samoa per year?
Your response must be concise. 42.85. In the year 2000, what is the difference between the Gross enrolment ratio (%) in Belarus and Gross enrolment ratio (%) in China?
Make the answer very short. 46.82. In the year 2000, what is the difference between the Gross enrolment ratio (%) of Belarus and Gross enrolment ratio (%) of Germany?
Ensure brevity in your answer.  -8.62. In the year 2000, what is the difference between the Gross enrolment ratio (%) of Belarus and Gross enrolment ratio (%) of Samoa?
Make the answer very short. 33.26. In the year 2000, what is the difference between the Gross enrolment ratio (%) in China and Gross enrolment ratio (%) in Germany?
Provide a short and direct response. -55.44. In the year 2000, what is the difference between the Gross enrolment ratio (%) in China and Gross enrolment ratio (%) in Samoa?
Your response must be concise. -13.56. In the year 2000, what is the difference between the Gross enrolment ratio (%) in Germany and Gross enrolment ratio (%) in Samoa?
Your response must be concise. 41.88. In the year 2001, what is the difference between the Gross enrolment ratio (%) in Belarus and Gross enrolment ratio (%) in China?
Your answer should be compact. 48.35. In the year 2001, what is the difference between the Gross enrolment ratio (%) in Belarus and Gross enrolment ratio (%) in Germany?
Your response must be concise. -11.88. In the year 2001, what is the difference between the Gross enrolment ratio (%) of Belarus and Gross enrolment ratio (%) of Samoa?
Give a very brief answer. 35.08. In the year 2001, what is the difference between the Gross enrolment ratio (%) in China and Gross enrolment ratio (%) in Germany?
Make the answer very short. -60.23. In the year 2001, what is the difference between the Gross enrolment ratio (%) of China and Gross enrolment ratio (%) of Samoa?
Offer a terse response. -13.28. In the year 2001, what is the difference between the Gross enrolment ratio (%) in Germany and Gross enrolment ratio (%) in Samoa?
Your answer should be very brief. 46.96. In the year 2007, what is the difference between the Gross enrolment ratio (%) of Belarus and Gross enrolment ratio (%) of China?
Your answer should be compact. 55.49. In the year 2007, what is the difference between the Gross enrolment ratio (%) of Belarus and Gross enrolment ratio (%) of Germany?
Offer a very short reply. -1.73. In the year 2007, what is the difference between the Gross enrolment ratio (%) of Belarus and Gross enrolment ratio (%) of Samoa?
Keep it short and to the point. 58.54. In the year 2007, what is the difference between the Gross enrolment ratio (%) in China and Gross enrolment ratio (%) in Germany?
Provide a short and direct response. -57.22. In the year 2007, what is the difference between the Gross enrolment ratio (%) in China and Gross enrolment ratio (%) in Samoa?
Keep it short and to the point. 3.04. In the year 2007, what is the difference between the Gross enrolment ratio (%) of Germany and Gross enrolment ratio (%) of Samoa?
Ensure brevity in your answer.  60.27. In the year 2008, what is the difference between the Gross enrolment ratio (%) of Belarus and Gross enrolment ratio (%) of China?
Keep it short and to the point. 51.95. In the year 2008, what is the difference between the Gross enrolment ratio (%) of Belarus and Gross enrolment ratio (%) of Germany?
Your answer should be compact. -5.48. In the year 2008, what is the difference between the Gross enrolment ratio (%) in Belarus and Gross enrolment ratio (%) in Samoa?
Provide a short and direct response. 61.53. In the year 2008, what is the difference between the Gross enrolment ratio (%) of China and Gross enrolment ratio (%) of Germany?
Make the answer very short. -57.43. In the year 2008, what is the difference between the Gross enrolment ratio (%) of China and Gross enrolment ratio (%) of Samoa?
Provide a succinct answer. 9.58. In the year 2008, what is the difference between the Gross enrolment ratio (%) of Germany and Gross enrolment ratio (%) of Samoa?
Provide a short and direct response. 67.01. In the year 2009, what is the difference between the Gross enrolment ratio (%) of Belarus and Gross enrolment ratio (%) of China?
Make the answer very short. 46.9. In the year 2009, what is the difference between the Gross enrolment ratio (%) in Belarus and Gross enrolment ratio (%) in Germany?
Your answer should be very brief. -9.75. In the year 2009, what is the difference between the Gross enrolment ratio (%) of Belarus and Gross enrolment ratio (%) of Samoa?
Keep it short and to the point. 58.56. In the year 2009, what is the difference between the Gross enrolment ratio (%) in China and Gross enrolment ratio (%) in Germany?
Ensure brevity in your answer.  -56.65. In the year 2009, what is the difference between the Gross enrolment ratio (%) of China and Gross enrolment ratio (%) of Samoa?
Offer a very short reply. 11.66. In the year 2009, what is the difference between the Gross enrolment ratio (%) of Germany and Gross enrolment ratio (%) of Samoa?
Your answer should be very brief. 68.31. In the year 2010, what is the difference between the Gross enrolment ratio (%) of Belarus and Gross enrolment ratio (%) of China?
Ensure brevity in your answer.  45.64. In the year 2010, what is the difference between the Gross enrolment ratio (%) in Belarus and Gross enrolment ratio (%) in Germany?
Ensure brevity in your answer.  -8.46. In the year 2010, what is the difference between the Gross enrolment ratio (%) in Belarus and Gross enrolment ratio (%) in Samoa?
Provide a succinct answer. 66.09. In the year 2010, what is the difference between the Gross enrolment ratio (%) of China and Gross enrolment ratio (%) of Germany?
Ensure brevity in your answer.  -54.1. In the year 2010, what is the difference between the Gross enrolment ratio (%) in China and Gross enrolment ratio (%) in Samoa?
Provide a succinct answer. 20.45. In the year 2010, what is the difference between the Gross enrolment ratio (%) in Germany and Gross enrolment ratio (%) in Samoa?
Your answer should be very brief. 74.55. In the year 2011, what is the difference between the Gross enrolment ratio (%) in Belarus and Gross enrolment ratio (%) in China?
Offer a terse response. 42.54. In the year 2011, what is the difference between the Gross enrolment ratio (%) in Belarus and Gross enrolment ratio (%) in Germany?
Provide a succinct answer. -7. In the year 2011, what is the difference between the Gross enrolment ratio (%) of Belarus and Gross enrolment ratio (%) of Samoa?
Offer a very short reply. 65.7. In the year 2011, what is the difference between the Gross enrolment ratio (%) in China and Gross enrolment ratio (%) in Germany?
Your answer should be very brief. -49.54. In the year 2011, what is the difference between the Gross enrolment ratio (%) of China and Gross enrolment ratio (%) of Samoa?
Provide a short and direct response. 23.15. In the year 2011, what is the difference between the Gross enrolment ratio (%) in Germany and Gross enrolment ratio (%) in Samoa?
Ensure brevity in your answer.  72.69. In the year 2012, what is the difference between the Gross enrolment ratio (%) of Belarus and Gross enrolment ratio (%) of China?
Provide a succinct answer. 32.81. In the year 2012, what is the difference between the Gross enrolment ratio (%) of Belarus and Gross enrolment ratio (%) of Germany?
Provide a short and direct response. -9.79. In the year 2012, what is the difference between the Gross enrolment ratio (%) of Belarus and Gross enrolment ratio (%) of Samoa?
Your answer should be very brief. 68.8. In the year 2012, what is the difference between the Gross enrolment ratio (%) of China and Gross enrolment ratio (%) of Germany?
Your answer should be very brief. -42.6. In the year 2012, what is the difference between the Gross enrolment ratio (%) in China and Gross enrolment ratio (%) in Samoa?
Give a very brief answer. 35.99. In the year 2012, what is the difference between the Gross enrolment ratio (%) in Germany and Gross enrolment ratio (%) in Samoa?
Your answer should be compact. 78.59. What is the ratio of the Gross enrolment ratio (%) of Belarus in 2000 to that in 2001?
Provide a short and direct response. 0.97. What is the ratio of the Gross enrolment ratio (%) of China in 2000 to that in 2001?
Offer a very short reply. 0.98. What is the ratio of the Gross enrolment ratio (%) of Germany in 2000 to that in 2001?
Provide a short and direct response. 0.94. What is the ratio of the Gross enrolment ratio (%) in Samoa in 2000 to that in 2001?
Your answer should be very brief. 0.99. What is the ratio of the Gross enrolment ratio (%) in Belarus in 2000 to that in 2007?
Offer a very short reply. 0.81. What is the ratio of the Gross enrolment ratio (%) in China in 2000 to that in 2007?
Provide a short and direct response. 0.78. What is the ratio of the Gross enrolment ratio (%) in Germany in 2000 to that in 2007?
Offer a terse response. 0.88. What is the ratio of the Gross enrolment ratio (%) of Samoa in 2000 to that in 2007?
Offer a very short reply. 1.12. What is the ratio of the Gross enrolment ratio (%) of Belarus in 2000 to that in 2008?
Provide a short and direct response. 0.83. What is the ratio of the Gross enrolment ratio (%) of China in 2000 to that in 2008?
Ensure brevity in your answer.  0.75. What is the ratio of the Gross enrolment ratio (%) in Germany in 2000 to that in 2008?
Offer a very short reply. 0.87. What is the ratio of the Gross enrolment ratio (%) of Samoa in 2000 to that in 2008?
Your answer should be compact. 1.25. What is the ratio of the Gross enrolment ratio (%) in Belarus in 2000 to that in 2009?
Provide a short and direct response. 0.85. What is the ratio of the Gross enrolment ratio (%) of China in 2000 to that in 2009?
Your response must be concise. 0.73. What is the ratio of the Gross enrolment ratio (%) in Germany in 2000 to that in 2009?
Your answer should be compact. 0.86. What is the ratio of the Gross enrolment ratio (%) of Samoa in 2000 to that in 2009?
Your response must be concise. 1.26. What is the ratio of the Gross enrolment ratio (%) in Belarus in 2000 to that in 2010?
Ensure brevity in your answer.  0.84. What is the ratio of the Gross enrolment ratio (%) of China in 2000 to that in 2010?
Give a very brief answer. 0.69. What is the ratio of the Gross enrolment ratio (%) in Germany in 2000 to that in 2010?
Keep it short and to the point. 0.85. What is the ratio of the Gross enrolment ratio (%) in Samoa in 2000 to that in 2010?
Your response must be concise. 1.47. What is the ratio of the Gross enrolment ratio (%) of Belarus in 2000 to that in 2011?
Offer a very short reply. 0.82. What is the ratio of the Gross enrolment ratio (%) of China in 2000 to that in 2011?
Offer a very short reply. 0.62. What is the ratio of the Gross enrolment ratio (%) in Germany in 2000 to that in 2011?
Provide a short and direct response. 0.84. What is the ratio of the Gross enrolment ratio (%) in Samoa in 2000 to that in 2011?
Provide a succinct answer. 1.34. What is the ratio of the Gross enrolment ratio (%) of Belarus in 2000 to that in 2012?
Give a very brief answer. 0.83. What is the ratio of the Gross enrolment ratio (%) of China in 2000 to that in 2012?
Give a very brief answer. 0.55. What is the ratio of the Gross enrolment ratio (%) of Germany in 2000 to that in 2012?
Your response must be concise. 0.84. What is the ratio of the Gross enrolment ratio (%) of Samoa in 2000 to that in 2012?
Offer a terse response. 1.54. What is the ratio of the Gross enrolment ratio (%) of Belarus in 2001 to that in 2007?
Offer a terse response. 0.83. What is the ratio of the Gross enrolment ratio (%) in China in 2001 to that in 2007?
Give a very brief answer. 0.79. What is the ratio of the Gross enrolment ratio (%) in Germany in 2001 to that in 2007?
Provide a short and direct response. 0.93. What is the ratio of the Gross enrolment ratio (%) of Samoa in 2001 to that in 2007?
Your response must be concise. 1.13. What is the ratio of the Gross enrolment ratio (%) of Belarus in 2001 to that in 2008?
Ensure brevity in your answer.  0.85. What is the ratio of the Gross enrolment ratio (%) in China in 2001 to that in 2008?
Your response must be concise. 0.77. What is the ratio of the Gross enrolment ratio (%) in Germany in 2001 to that in 2008?
Your answer should be compact. 0.92. What is the ratio of the Gross enrolment ratio (%) of Samoa in 2001 to that in 2008?
Ensure brevity in your answer.  1.26. What is the ratio of the Gross enrolment ratio (%) in Belarus in 2001 to that in 2009?
Offer a very short reply. 0.88. What is the ratio of the Gross enrolment ratio (%) in China in 2001 to that in 2009?
Your answer should be very brief. 0.74. What is the ratio of the Gross enrolment ratio (%) of Germany in 2001 to that in 2009?
Give a very brief answer. 0.91. What is the ratio of the Gross enrolment ratio (%) in Samoa in 2001 to that in 2009?
Make the answer very short. 1.27. What is the ratio of the Gross enrolment ratio (%) in Belarus in 2001 to that in 2010?
Ensure brevity in your answer.  0.86. What is the ratio of the Gross enrolment ratio (%) of China in 2001 to that in 2010?
Offer a very short reply. 0.7. What is the ratio of the Gross enrolment ratio (%) in Germany in 2001 to that in 2010?
Offer a very short reply. 0.91. What is the ratio of the Gross enrolment ratio (%) of Samoa in 2001 to that in 2010?
Offer a very short reply. 1.48. What is the ratio of the Gross enrolment ratio (%) in Belarus in 2001 to that in 2011?
Give a very brief answer. 0.84. What is the ratio of the Gross enrolment ratio (%) of China in 2001 to that in 2011?
Provide a short and direct response. 0.63. What is the ratio of the Gross enrolment ratio (%) of Germany in 2001 to that in 2011?
Ensure brevity in your answer.  0.89. What is the ratio of the Gross enrolment ratio (%) in Samoa in 2001 to that in 2011?
Make the answer very short. 1.35. What is the ratio of the Gross enrolment ratio (%) of Belarus in 2001 to that in 2012?
Provide a succinct answer. 0.85. What is the ratio of the Gross enrolment ratio (%) of China in 2001 to that in 2012?
Provide a succinct answer. 0.56. What is the ratio of the Gross enrolment ratio (%) in Germany in 2001 to that in 2012?
Provide a succinct answer. 0.89. What is the ratio of the Gross enrolment ratio (%) in Samoa in 2001 to that in 2012?
Ensure brevity in your answer.  1.55. What is the ratio of the Gross enrolment ratio (%) of Belarus in 2007 to that in 2008?
Your answer should be very brief. 1.02. What is the ratio of the Gross enrolment ratio (%) of China in 2007 to that in 2008?
Make the answer very short. 0.97. What is the ratio of the Gross enrolment ratio (%) in Germany in 2007 to that in 2008?
Offer a terse response. 0.98. What is the ratio of the Gross enrolment ratio (%) of Samoa in 2007 to that in 2008?
Keep it short and to the point. 1.12. What is the ratio of the Gross enrolment ratio (%) of Belarus in 2007 to that in 2009?
Your answer should be very brief. 1.05. What is the ratio of the Gross enrolment ratio (%) in China in 2007 to that in 2009?
Ensure brevity in your answer.  0.94. What is the ratio of the Gross enrolment ratio (%) in Germany in 2007 to that in 2009?
Make the answer very short. 0.97. What is the ratio of the Gross enrolment ratio (%) of Samoa in 2007 to that in 2009?
Keep it short and to the point. 1.13. What is the ratio of the Gross enrolment ratio (%) of Belarus in 2007 to that in 2010?
Your answer should be compact. 1.04. What is the ratio of the Gross enrolment ratio (%) in China in 2007 to that in 2010?
Give a very brief answer. 0.89. What is the ratio of the Gross enrolment ratio (%) of Germany in 2007 to that in 2010?
Provide a succinct answer. 0.97. What is the ratio of the Gross enrolment ratio (%) of Samoa in 2007 to that in 2010?
Offer a very short reply. 1.31. What is the ratio of the Gross enrolment ratio (%) in Belarus in 2007 to that in 2011?
Your answer should be very brief. 1.01. What is the ratio of the Gross enrolment ratio (%) of China in 2007 to that in 2011?
Your answer should be compact. 0.8. What is the ratio of the Gross enrolment ratio (%) in Germany in 2007 to that in 2011?
Provide a short and direct response. 0.96. What is the ratio of the Gross enrolment ratio (%) in Samoa in 2007 to that in 2011?
Provide a short and direct response. 1.2. What is the ratio of the Gross enrolment ratio (%) of Belarus in 2007 to that in 2012?
Offer a very short reply. 1.02. What is the ratio of the Gross enrolment ratio (%) of China in 2007 to that in 2012?
Offer a very short reply. 0.71. What is the ratio of the Gross enrolment ratio (%) in Germany in 2007 to that in 2012?
Your answer should be compact. 0.95. What is the ratio of the Gross enrolment ratio (%) in Samoa in 2007 to that in 2012?
Ensure brevity in your answer.  1.38. What is the ratio of the Gross enrolment ratio (%) in Belarus in 2008 to that in 2009?
Your answer should be compact. 1.03. What is the ratio of the Gross enrolment ratio (%) of China in 2008 to that in 2009?
Provide a succinct answer. 0.96. What is the ratio of the Gross enrolment ratio (%) of Germany in 2008 to that in 2009?
Your answer should be compact. 0.99. What is the ratio of the Gross enrolment ratio (%) in Samoa in 2008 to that in 2009?
Offer a very short reply. 1.01. What is the ratio of the Gross enrolment ratio (%) in Belarus in 2008 to that in 2010?
Provide a short and direct response. 1.02. What is the ratio of the Gross enrolment ratio (%) of China in 2008 to that in 2010?
Give a very brief answer. 0.92. What is the ratio of the Gross enrolment ratio (%) of Germany in 2008 to that in 2010?
Offer a very short reply. 0.99. What is the ratio of the Gross enrolment ratio (%) of Samoa in 2008 to that in 2010?
Offer a very short reply. 1.17. What is the ratio of the Gross enrolment ratio (%) in Belarus in 2008 to that in 2011?
Provide a succinct answer. 0.99. What is the ratio of the Gross enrolment ratio (%) in China in 2008 to that in 2011?
Keep it short and to the point. 0.83. What is the ratio of the Gross enrolment ratio (%) in Germany in 2008 to that in 2011?
Offer a very short reply. 0.97. What is the ratio of the Gross enrolment ratio (%) in Samoa in 2008 to that in 2011?
Offer a very short reply. 1.07. What is the ratio of the Gross enrolment ratio (%) in China in 2008 to that in 2012?
Your answer should be compact. 0.73. What is the ratio of the Gross enrolment ratio (%) in Germany in 2008 to that in 2012?
Give a very brief answer. 0.97. What is the ratio of the Gross enrolment ratio (%) of Samoa in 2008 to that in 2012?
Give a very brief answer. 1.23. What is the ratio of the Gross enrolment ratio (%) in Belarus in 2009 to that in 2010?
Your answer should be very brief. 0.98. What is the ratio of the Gross enrolment ratio (%) in China in 2009 to that in 2010?
Provide a short and direct response. 0.95. What is the ratio of the Gross enrolment ratio (%) of Germany in 2009 to that in 2010?
Your response must be concise. 1. What is the ratio of the Gross enrolment ratio (%) of Samoa in 2009 to that in 2010?
Offer a terse response. 1.17. What is the ratio of the Gross enrolment ratio (%) in Belarus in 2009 to that in 2011?
Give a very brief answer. 0.96. What is the ratio of the Gross enrolment ratio (%) of China in 2009 to that in 2011?
Give a very brief answer. 0.86. What is the ratio of the Gross enrolment ratio (%) of Germany in 2009 to that in 2011?
Ensure brevity in your answer.  0.98. What is the ratio of the Gross enrolment ratio (%) in Samoa in 2009 to that in 2011?
Keep it short and to the point. 1.07. What is the ratio of the Gross enrolment ratio (%) of Belarus in 2009 to that in 2012?
Provide a succinct answer. 0.97. What is the ratio of the Gross enrolment ratio (%) in China in 2009 to that in 2012?
Your answer should be very brief. 0.76. What is the ratio of the Gross enrolment ratio (%) in Germany in 2009 to that in 2012?
Your response must be concise. 0.98. What is the ratio of the Gross enrolment ratio (%) in Samoa in 2009 to that in 2012?
Provide a short and direct response. 1.22. What is the ratio of the Gross enrolment ratio (%) of Belarus in 2010 to that in 2011?
Give a very brief answer. 0.97. What is the ratio of the Gross enrolment ratio (%) in China in 2010 to that in 2011?
Keep it short and to the point. 0.9. What is the ratio of the Gross enrolment ratio (%) in Germany in 2010 to that in 2011?
Provide a short and direct response. 0.99. What is the ratio of the Gross enrolment ratio (%) in Samoa in 2010 to that in 2011?
Keep it short and to the point. 0.91. What is the ratio of the Gross enrolment ratio (%) of China in 2010 to that in 2012?
Keep it short and to the point. 0.8. What is the ratio of the Gross enrolment ratio (%) of Germany in 2010 to that in 2012?
Provide a short and direct response. 0.98. What is the ratio of the Gross enrolment ratio (%) of Samoa in 2010 to that in 2012?
Offer a very short reply. 1.05. What is the ratio of the Gross enrolment ratio (%) in Belarus in 2011 to that in 2012?
Provide a succinct answer. 1.02. What is the ratio of the Gross enrolment ratio (%) in China in 2011 to that in 2012?
Make the answer very short. 0.89. What is the ratio of the Gross enrolment ratio (%) of Germany in 2011 to that in 2012?
Offer a terse response. 0.99. What is the ratio of the Gross enrolment ratio (%) of Samoa in 2011 to that in 2012?
Keep it short and to the point. 1.15. What is the difference between the highest and the second highest Gross enrolment ratio (%) of Belarus?
Provide a short and direct response. 0.63. What is the difference between the highest and the second highest Gross enrolment ratio (%) in China?
Your answer should be compact. 7.9. What is the difference between the highest and the second highest Gross enrolment ratio (%) of Germany?
Your response must be concise. 0.97. What is the difference between the highest and the second highest Gross enrolment ratio (%) of Samoa?
Your answer should be compact. 0.51. What is the difference between the highest and the lowest Gross enrolment ratio (%) in Belarus?
Offer a terse response. 19.79. What is the difference between the highest and the lowest Gross enrolment ratio (%) of China?
Keep it short and to the point. 31.34. What is the difference between the highest and the lowest Gross enrolment ratio (%) in Germany?
Your response must be concise. 18.5. What is the difference between the highest and the lowest Gross enrolment ratio (%) of Samoa?
Offer a terse response. 18.72. 